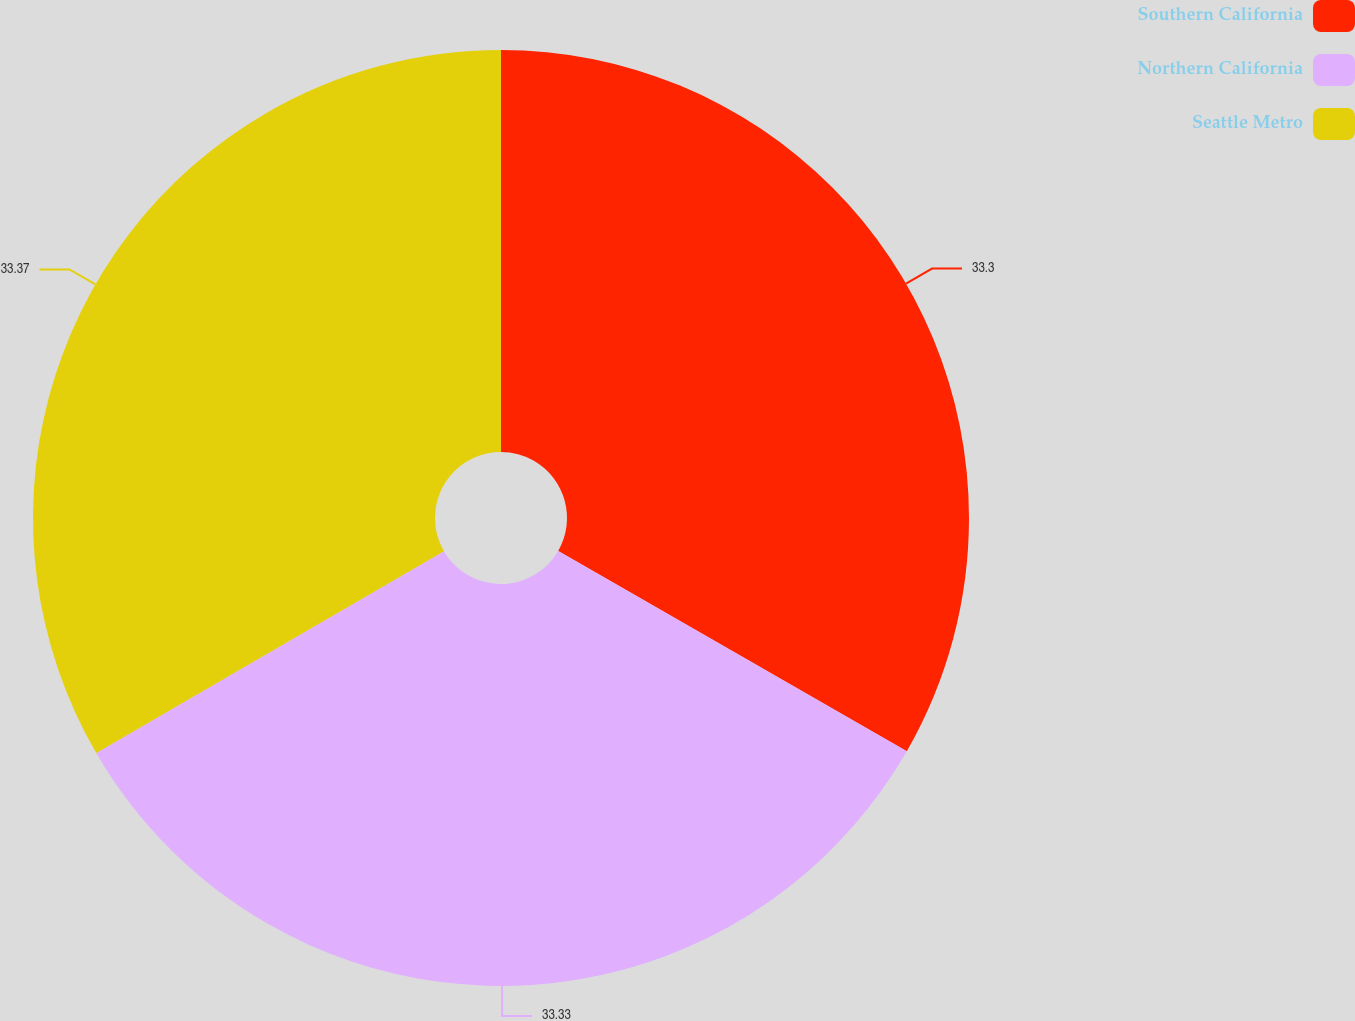Convert chart to OTSL. <chart><loc_0><loc_0><loc_500><loc_500><pie_chart><fcel>Southern California<fcel>Northern California<fcel>Seattle Metro<nl><fcel>33.3%<fcel>33.33%<fcel>33.37%<nl></chart> 